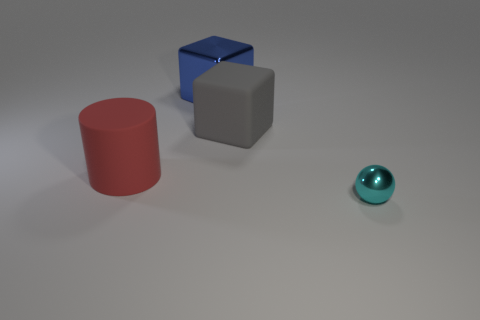Is there a cyan shiny thing? yes 